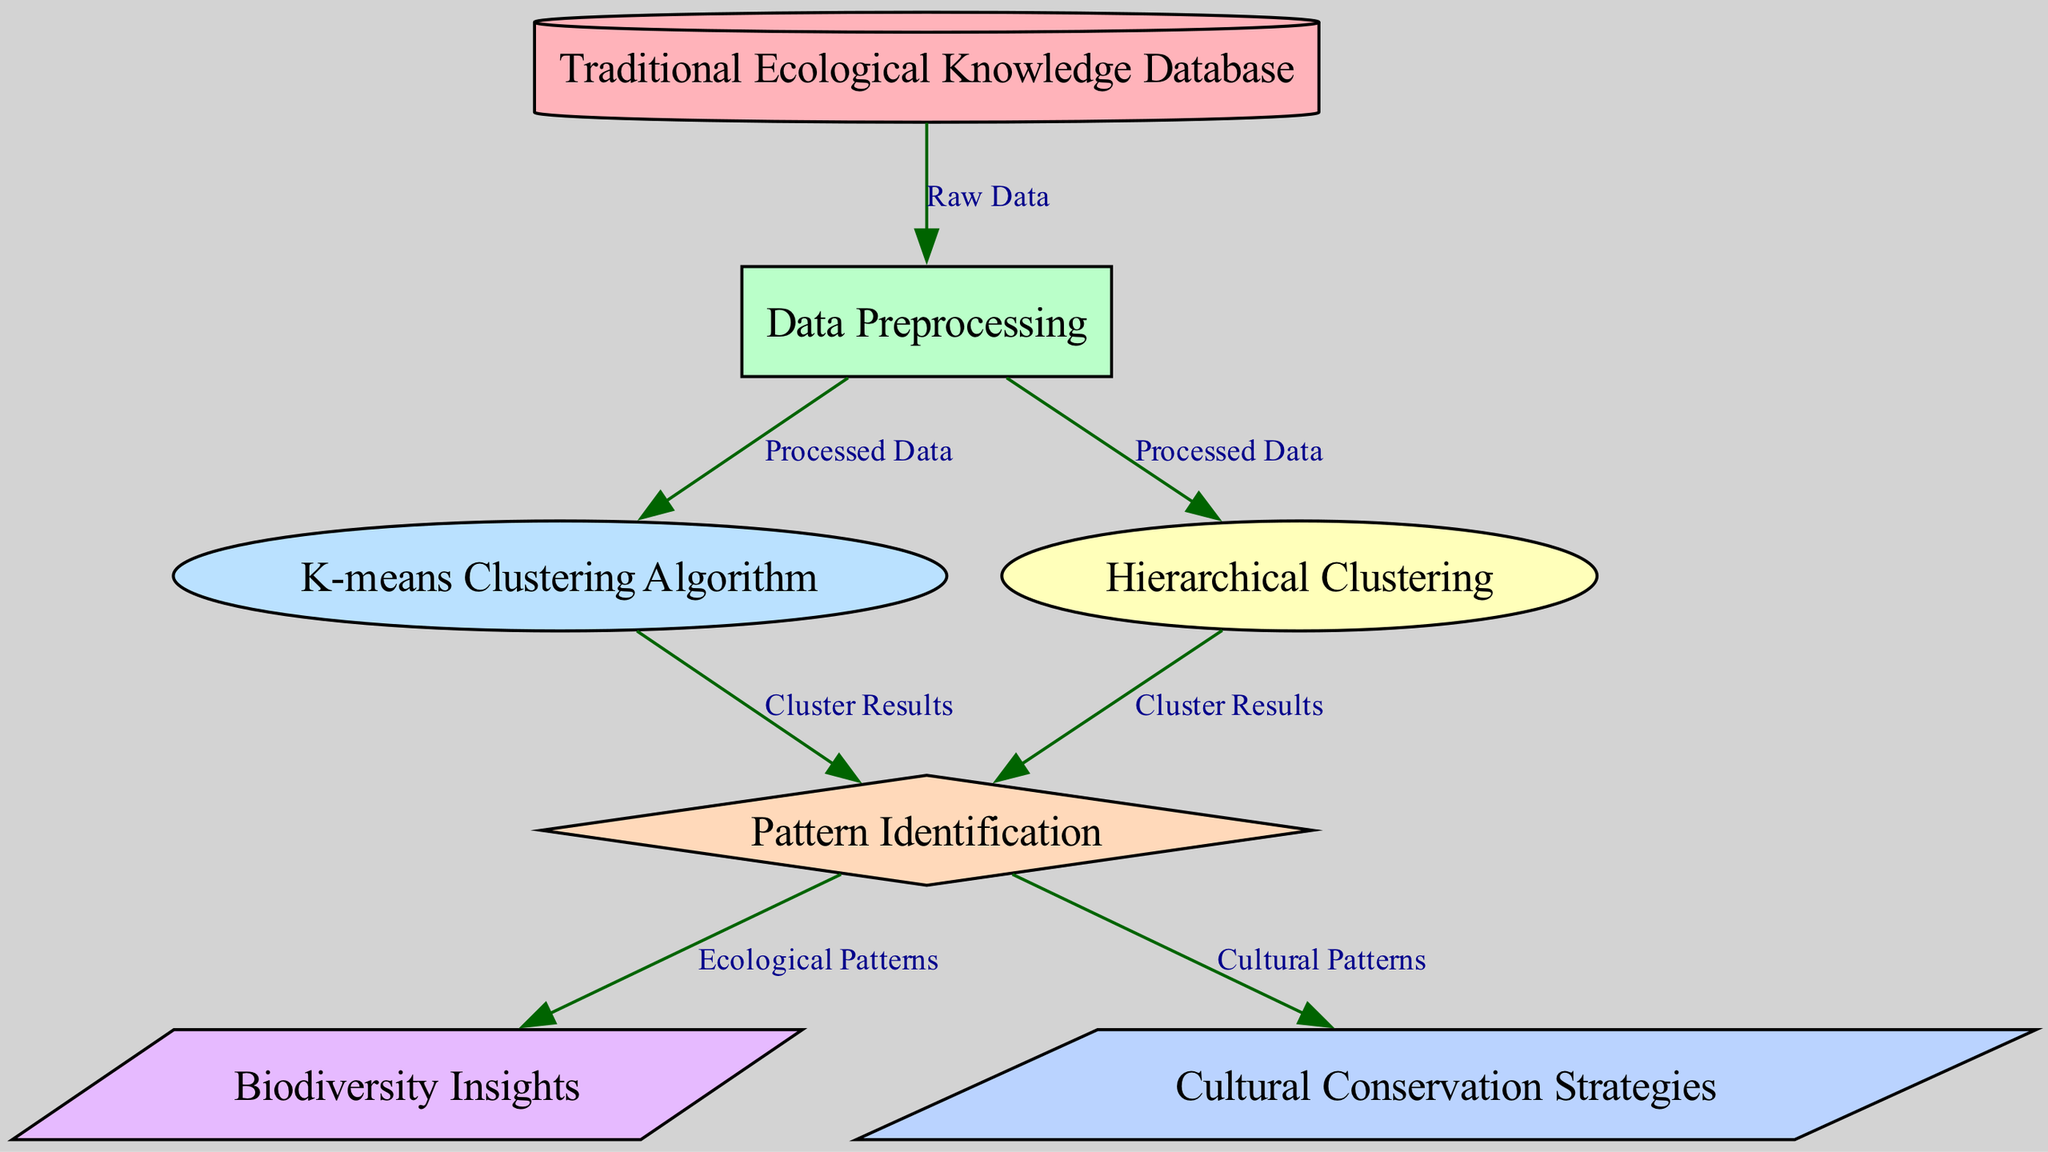What is the first node in the diagram? The first node is labeled "Traditional Ecological Knowledge Database," which is the starting point of the diagram.
Answer: Traditional Ecological Knowledge Database How many nodes are present in the diagram? By counting each unique node listed, there are seven nodes in total.
Answer: 7 What type of algorithm is represented by node 3? Node 3 is labeled "K-means Clustering Algorithm," which is a specific type of clustering method used for pattern recognition in data sets.
Answer: K-means Clustering Algorithm What do the edges from nodes 2 to nodes 3 and 4 represent? The edges from node 2 (Data Preprocessing) to nodes 3 (K-means Clustering Algorithm) and 4 (Hierarchical Clustering) represent the transition from processed data to specific clustering results, indicating the output of the preprocessing step.
Answer: Processed Data How do "Ecological Patterns" connect to the rest of the diagram? "Ecological Patterns" is derived from the "Pattern Identification" node, which is connected to both clustering nodes, indicating that patterns identified are related to biodiversity insights and cultural insights.
Answer: From Pattern Identification What is the purpose of node 5 in the context of the diagram? Node 5, labeled "Pattern Identification," serves as a pivotal stage where the clustering results from nodes 3 and 4 are analyzed to extract meaningful patterns related to ecology and culture.
Answer: Identify patterns Which node yields insights related to biodiversity? The node labeled "Biodiversity Insights" receives its input from "Pattern Identification," therefore it represents the output from analyzing ecological patterns identified through clustering.
Answer: Biodiversity Insights What is the relationship between clustering results and cultural patterns? Both K-means and Hierarchical clustering lead to cluster results that inform cultural patterns, indicating a connection between identified knowledge patterns and cultural conservation efforts.
Answer: Cluster Results 